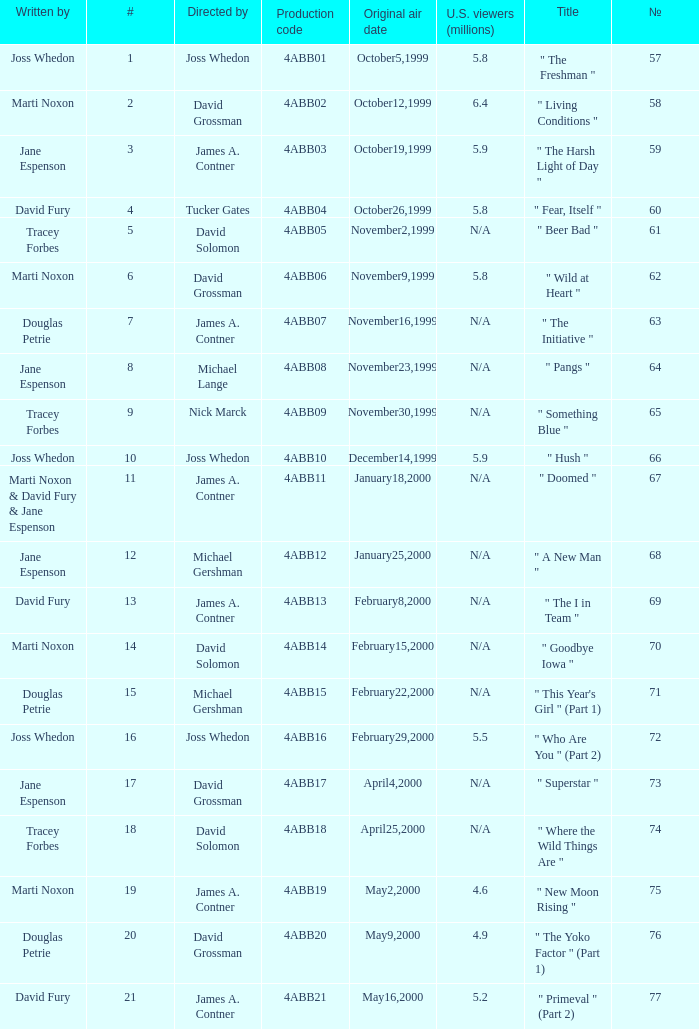What is the series No when the season 4 # is 18? 74.0. 